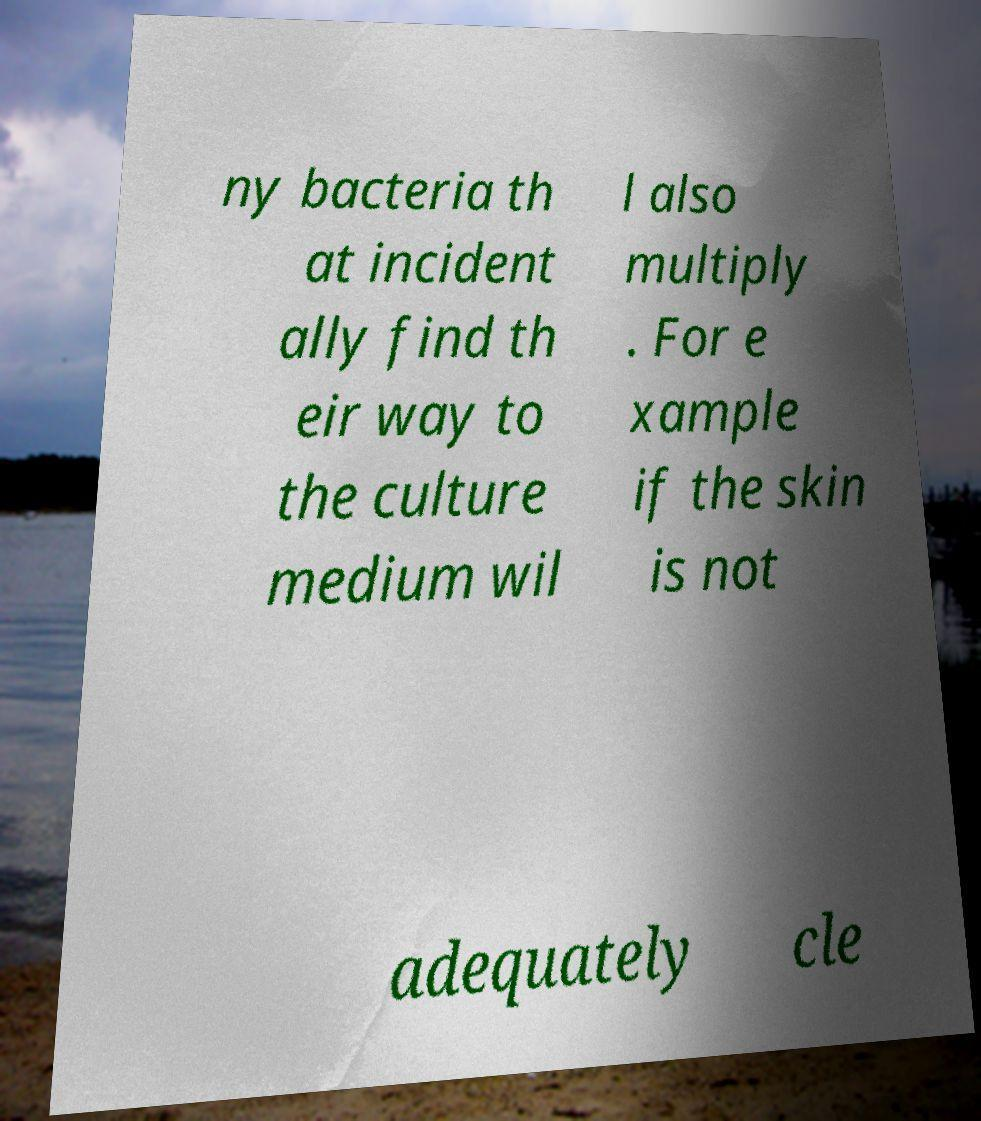What messages or text are displayed in this image? I need them in a readable, typed format. ny bacteria th at incident ally find th eir way to the culture medium wil l also multiply . For e xample if the skin is not adequately cle 